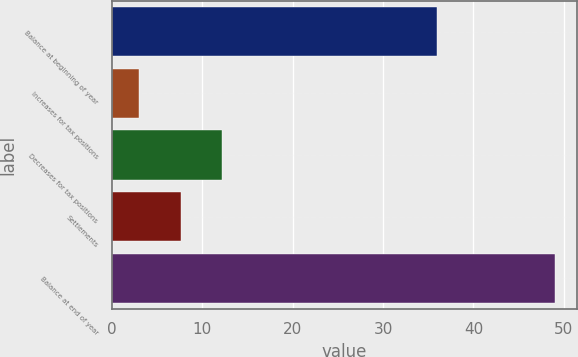Convert chart to OTSL. <chart><loc_0><loc_0><loc_500><loc_500><bar_chart><fcel>Balance at beginning of year<fcel>Increases for tax positions<fcel>Decreases for tax positions<fcel>Settlements<fcel>Balance at end of year<nl><fcel>36<fcel>3<fcel>12.2<fcel>7.6<fcel>49<nl></chart> 